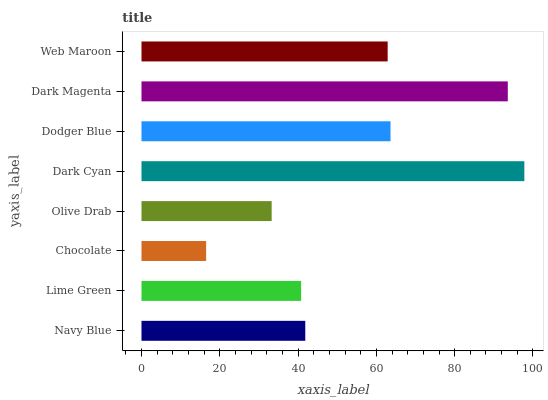Is Chocolate the minimum?
Answer yes or no. Yes. Is Dark Cyan the maximum?
Answer yes or no. Yes. Is Lime Green the minimum?
Answer yes or no. No. Is Lime Green the maximum?
Answer yes or no. No. Is Navy Blue greater than Lime Green?
Answer yes or no. Yes. Is Lime Green less than Navy Blue?
Answer yes or no. Yes. Is Lime Green greater than Navy Blue?
Answer yes or no. No. Is Navy Blue less than Lime Green?
Answer yes or no. No. Is Web Maroon the high median?
Answer yes or no. Yes. Is Navy Blue the low median?
Answer yes or no. Yes. Is Chocolate the high median?
Answer yes or no. No. Is Dark Cyan the low median?
Answer yes or no. No. 